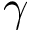<formula> <loc_0><loc_0><loc_500><loc_500>\gamma</formula> 